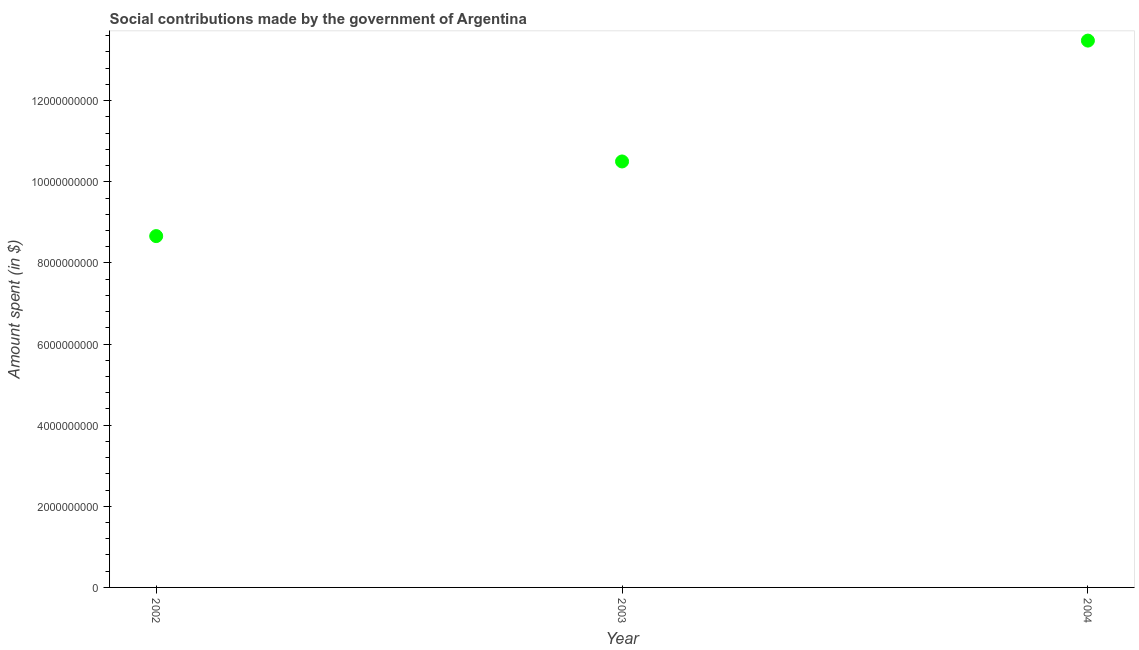What is the amount spent in making social contributions in 2002?
Ensure brevity in your answer.  8.66e+09. Across all years, what is the maximum amount spent in making social contributions?
Keep it short and to the point. 1.35e+1. Across all years, what is the minimum amount spent in making social contributions?
Provide a short and direct response. 8.66e+09. In which year was the amount spent in making social contributions maximum?
Give a very brief answer. 2004. In which year was the amount spent in making social contributions minimum?
Provide a short and direct response. 2002. What is the sum of the amount spent in making social contributions?
Provide a succinct answer. 3.26e+1. What is the difference between the amount spent in making social contributions in 2002 and 2004?
Offer a terse response. -4.82e+09. What is the average amount spent in making social contributions per year?
Give a very brief answer. 1.09e+1. What is the median amount spent in making social contributions?
Offer a terse response. 1.05e+1. In how many years, is the amount spent in making social contributions greater than 10400000000 $?
Your response must be concise. 2. Do a majority of the years between 2002 and 2004 (inclusive) have amount spent in making social contributions greater than 8400000000 $?
Offer a terse response. Yes. What is the ratio of the amount spent in making social contributions in 2002 to that in 2004?
Your answer should be compact. 0.64. Is the amount spent in making social contributions in 2002 less than that in 2003?
Offer a terse response. Yes. What is the difference between the highest and the second highest amount spent in making social contributions?
Offer a very short reply. 2.98e+09. What is the difference between the highest and the lowest amount spent in making social contributions?
Give a very brief answer. 4.82e+09. In how many years, is the amount spent in making social contributions greater than the average amount spent in making social contributions taken over all years?
Your answer should be compact. 1. Does the amount spent in making social contributions monotonically increase over the years?
Make the answer very short. Yes. How many dotlines are there?
Provide a succinct answer. 1. Does the graph contain any zero values?
Ensure brevity in your answer.  No. What is the title of the graph?
Offer a very short reply. Social contributions made by the government of Argentina. What is the label or title of the X-axis?
Keep it short and to the point. Year. What is the label or title of the Y-axis?
Your answer should be very brief. Amount spent (in $). What is the Amount spent (in $) in 2002?
Make the answer very short. 8.66e+09. What is the Amount spent (in $) in 2003?
Make the answer very short. 1.05e+1. What is the Amount spent (in $) in 2004?
Your response must be concise. 1.35e+1. What is the difference between the Amount spent (in $) in 2002 and 2003?
Offer a terse response. -1.84e+09. What is the difference between the Amount spent (in $) in 2002 and 2004?
Your answer should be compact. -4.82e+09. What is the difference between the Amount spent (in $) in 2003 and 2004?
Offer a terse response. -2.98e+09. What is the ratio of the Amount spent (in $) in 2002 to that in 2003?
Provide a succinct answer. 0.82. What is the ratio of the Amount spent (in $) in 2002 to that in 2004?
Your response must be concise. 0.64. What is the ratio of the Amount spent (in $) in 2003 to that in 2004?
Your answer should be compact. 0.78. 